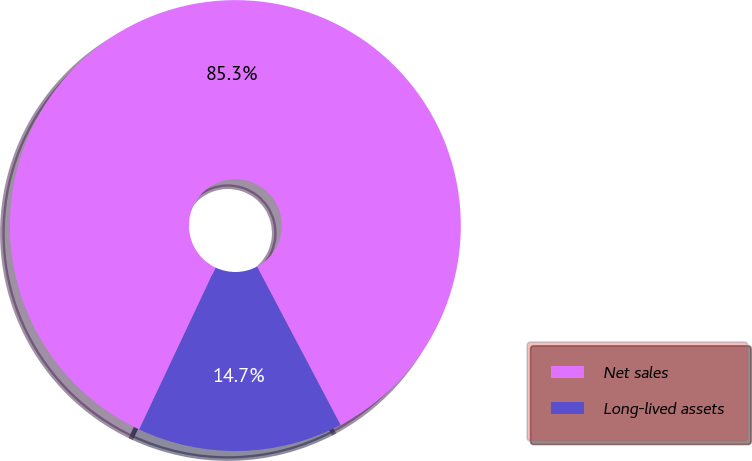<chart> <loc_0><loc_0><loc_500><loc_500><pie_chart><fcel>Net sales<fcel>Long-lived assets<nl><fcel>85.26%<fcel>14.74%<nl></chart> 